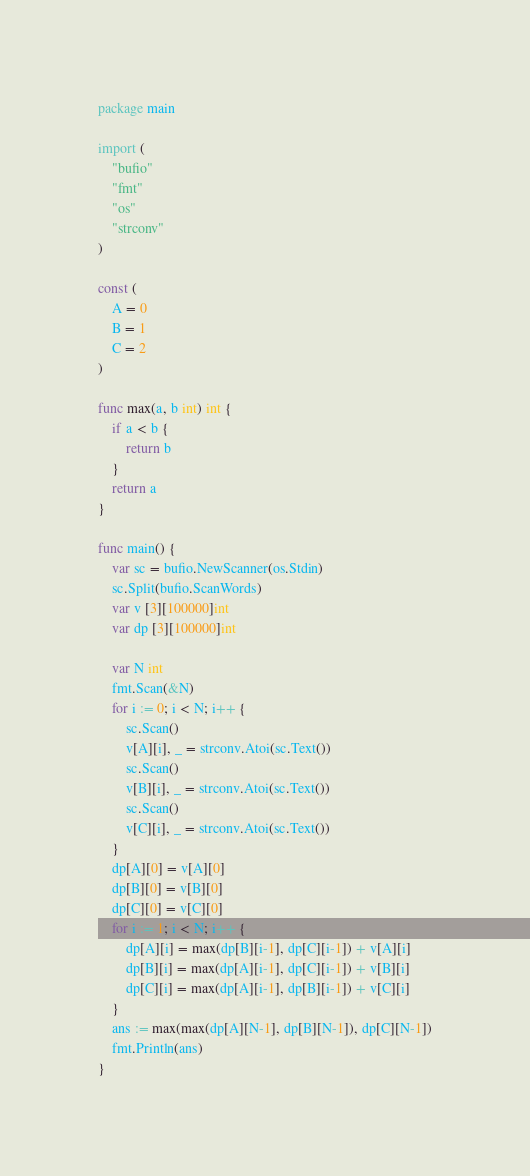<code> <loc_0><loc_0><loc_500><loc_500><_Go_>package main

import (
	"bufio"
	"fmt"
	"os"
	"strconv"
)

const (
	A = 0
	B = 1
	C = 2
)

func max(a, b int) int {
	if a < b {
		return b
	}
	return a
}

func main() {
	var sc = bufio.NewScanner(os.Stdin)
	sc.Split(bufio.ScanWords)
	var v [3][100000]int
	var dp [3][100000]int

	var N int
	fmt.Scan(&N)
	for i := 0; i < N; i++ {
		sc.Scan()
		v[A][i], _ = strconv.Atoi(sc.Text())
		sc.Scan()
		v[B][i], _ = strconv.Atoi(sc.Text())
		sc.Scan()
		v[C][i], _ = strconv.Atoi(sc.Text())
	}
	dp[A][0] = v[A][0]
	dp[B][0] = v[B][0]
	dp[C][0] = v[C][0]
	for i := 1; i < N; i++ {
		dp[A][i] = max(dp[B][i-1], dp[C][i-1]) + v[A][i]
		dp[B][i] = max(dp[A][i-1], dp[C][i-1]) + v[B][i]
		dp[C][i] = max(dp[A][i-1], dp[B][i-1]) + v[C][i]
	}
	ans := max(max(dp[A][N-1], dp[B][N-1]), dp[C][N-1])
	fmt.Println(ans)
}
</code> 